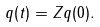<formula> <loc_0><loc_0><loc_500><loc_500>q ( t ) = Z q ( 0 ) .</formula> 